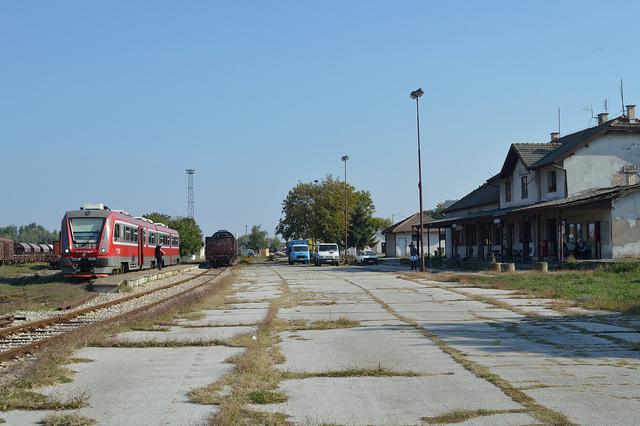How many light posts are in the picture?
Keep it brief. 2. Does this train work?
Keep it brief. Yes. Is the street busy with cars?
Answer briefly. No. Is the train moving?
Be succinct. No. Is this out in the desert?
Be succinct. No. What in the street?
Answer briefly. Grass. What do you see a shadow of at the front of the picture?
Keep it brief. Tree. What condition is the grass in?
Concise answer only. Poor. What season is shown in the photo?
Be succinct. Spring. How many tracks are there?
Be succinct. 1. What color is the van?
Give a very brief answer. White. How many trees are there?
Give a very brief answer. 5. Is it cold?
Quick response, please. No. 